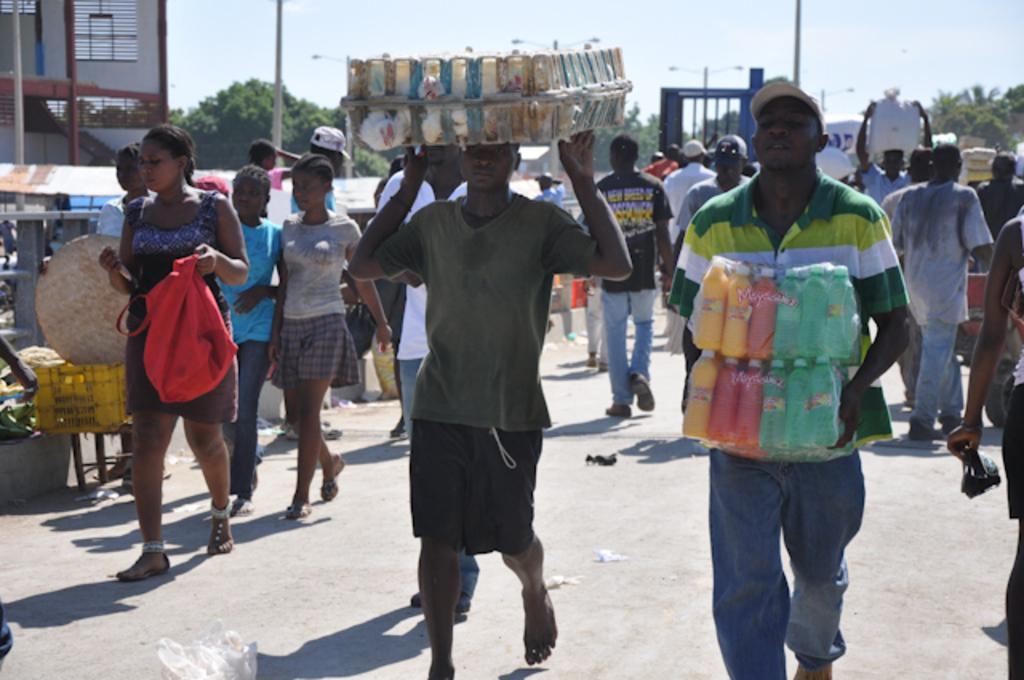Describe this image in one or two sentences. There is one person walking on the road and holding some bottles and the person standing on the right side to him is also holding some bottles. The person standing on the left side is holding a red color bag. There are some other persons standing in the middle of this image. There are some trees in the background. There is building on the left side of this image. 